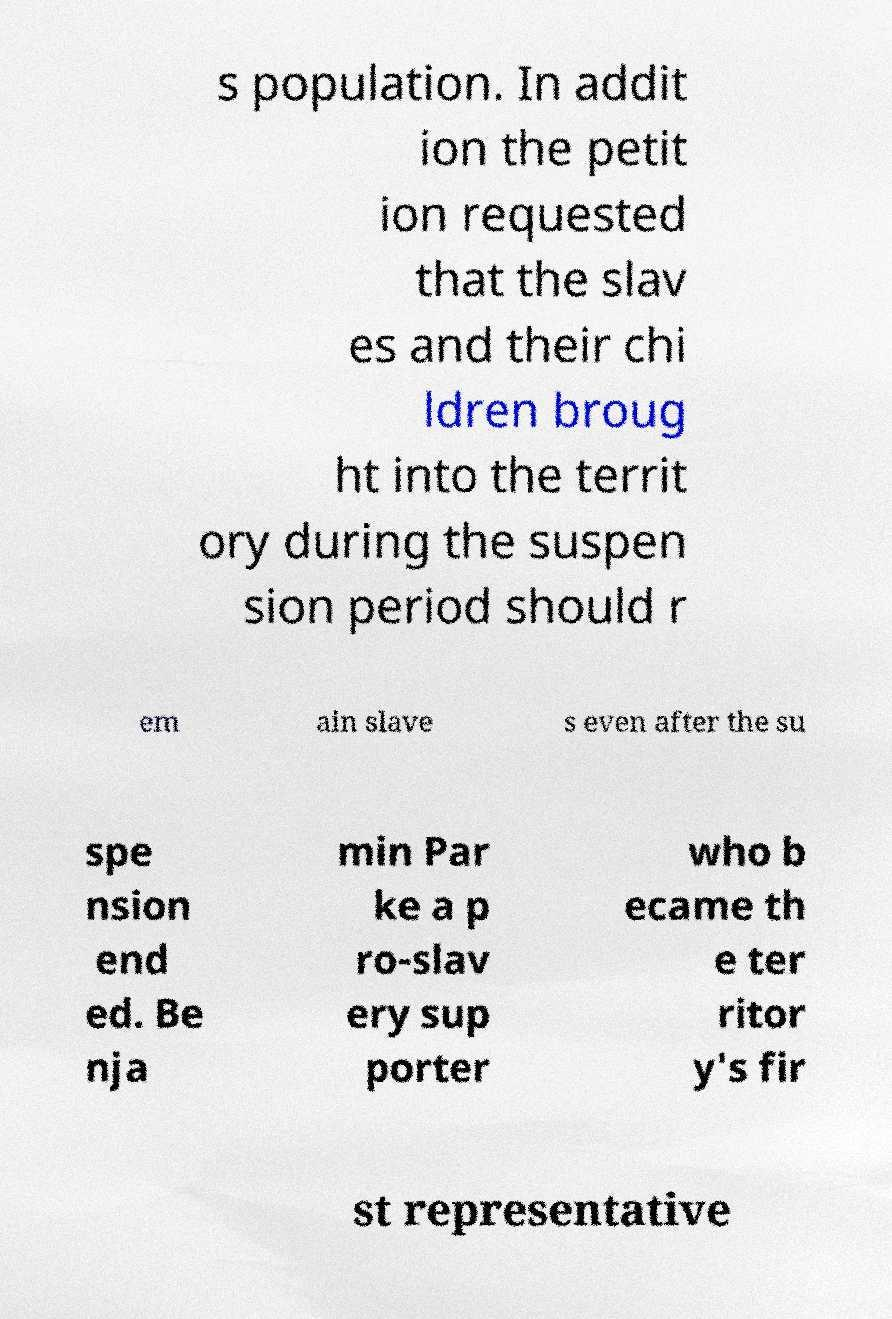Could you extract and type out the text from this image? s population. In addit ion the petit ion requested that the slav es and their chi ldren broug ht into the territ ory during the suspen sion period should r em ain slave s even after the su spe nsion end ed. Be nja min Par ke a p ro-slav ery sup porter who b ecame th e ter ritor y's fir st representative 